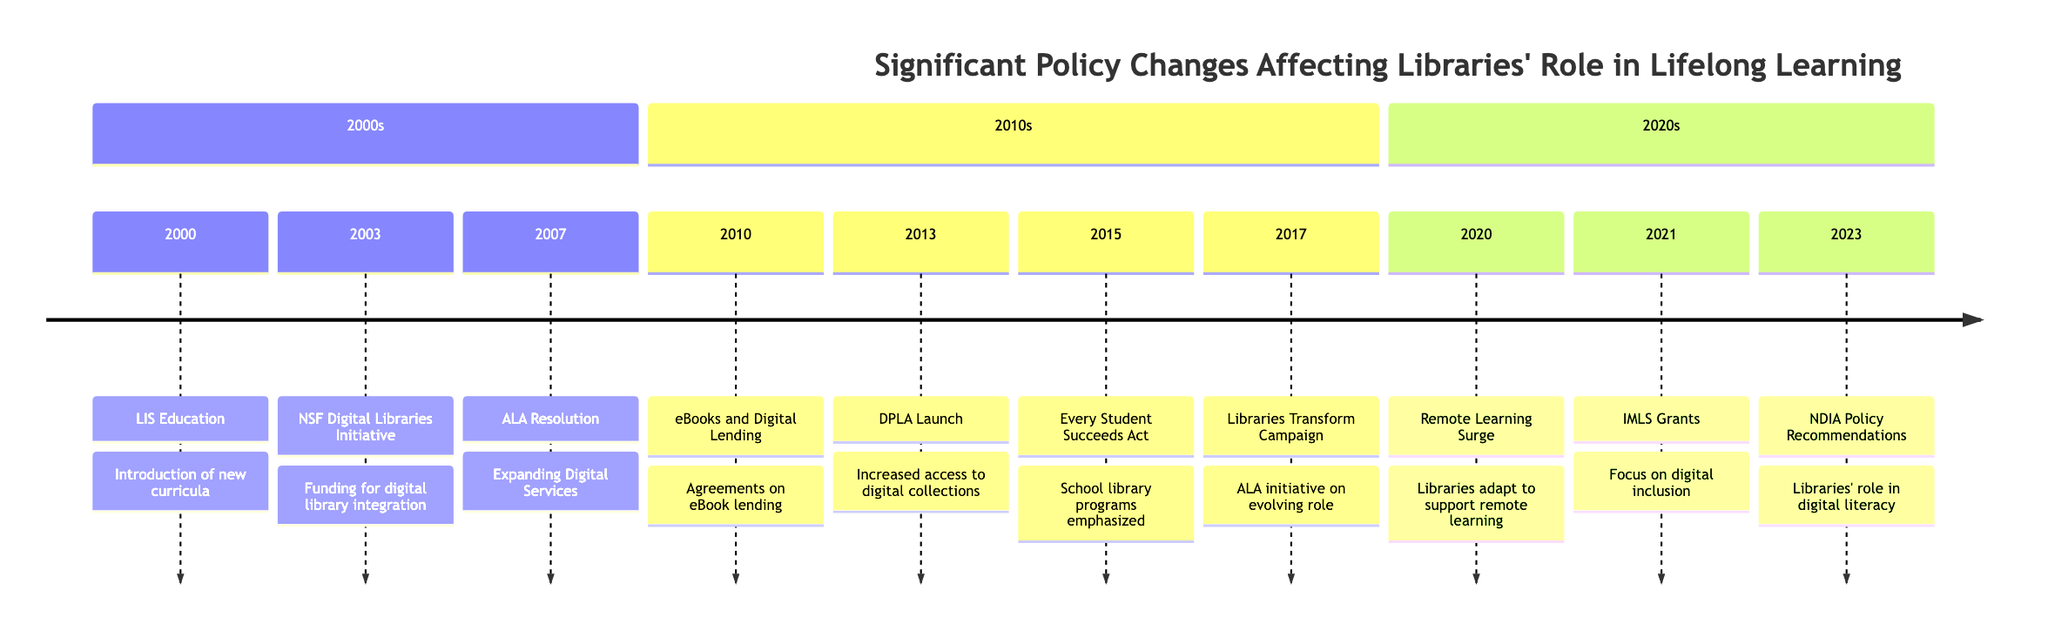What event occurred in 2000? The diagram shows that in 2000, the event was "LIS Education," which highlights the introduction of new curricula in Library and Information Science programs.
Answer: LIS Education How many events are listed in the 2010s section? By counting the nodes in the 2010s section of the timeline, we see there are four events: eBooks and Digital Lending, DPLA Launch, Every Student Succeeds Act, and Libraries Transform Campaign.
Answer: 4 What initiative was launched in 2017? In the timeline, it indicates that in 2017, the "Libraries Transform Campaign" was launched as an ALA initiative demonstrating the evolving role of libraries.
Answer: Libraries Transform Campaign Which event emphasizes digital inclusion and lifelong learning programs? The diagram lists "IMLS Grants" in 2021 as the event that focuses on digital inclusion and lifelong learning programs, highlighting grants provided by the Institute of Museum and Library Services.
Answer: IMLS Grants What did the ALA resolution in 2007 call for? According to the timeline, the 2007 ALA Resolution called for "Expanding Digital Services," which emphasizes the increased availability of digital resources to support lifelong learning.
Answer: Expanding Digital Services What significant change happened in 2020 due to the global situation? The timeline notes that in 2020, there was a "Remote Learning Surge Due to COVID-19," indicating that libraries adapted their services to support this shift in learning.
Answer: Remote Learning Surge What is the purpose of the National Digital Inclusion Alliance's recommendations released in 2023? The 2023 entry highlights that the National Digital Inclusion Alliance released "Policy Recommendations," emphasizing the role of libraries in promoting digital literacy and lifelong learning programs.
Answer: Policy Recommendations What year saw the establishment of the Digital Public Library of America? The diagram shows that the "DPLA Launch" occurred in 2013, marking the establishment of this significant digital library aimed at increasing access to digital collections.
Answer: 2013 What role does the Every Student Succeeds Act indicate for libraries? The timeline details that the "Every Student Succeeds Act" in 2015 emphasizes the role of libraries in supporting educational outcomes for students.
Answer: Supporting educational outcomes 